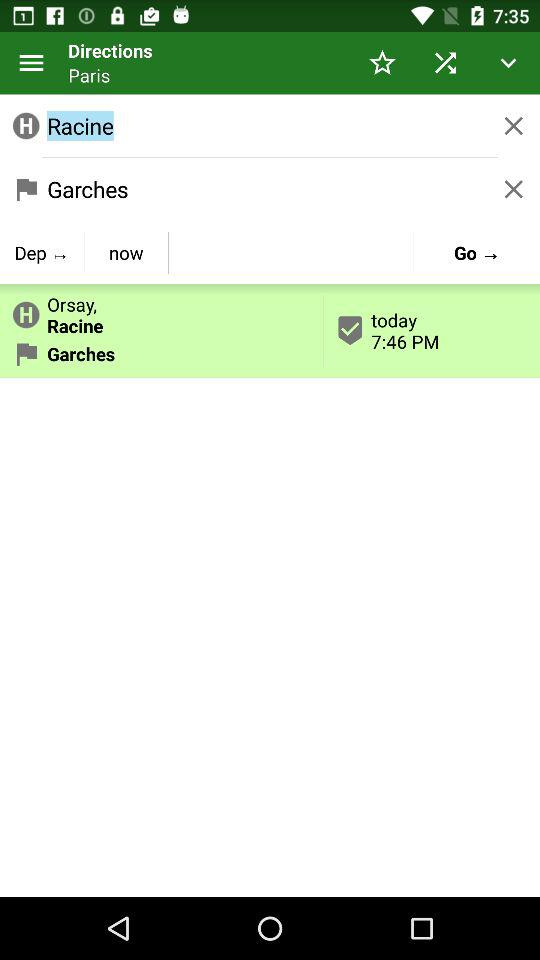What is the displayed time? The displayed time is 7:46 PM. 